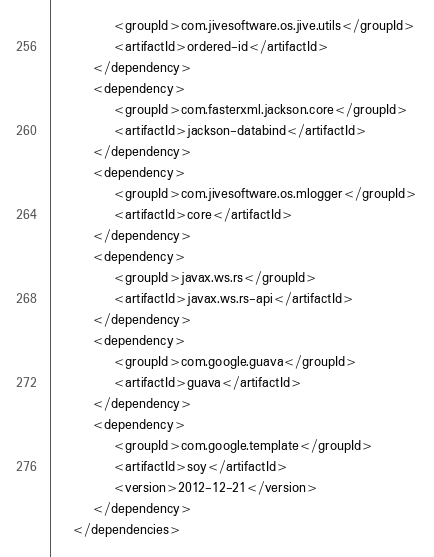Convert code to text. <code><loc_0><loc_0><loc_500><loc_500><_XML_>            <groupId>com.jivesoftware.os.jive.utils</groupId>
            <artifactId>ordered-id</artifactId>
        </dependency>
        <dependency>
            <groupId>com.fasterxml.jackson.core</groupId>
            <artifactId>jackson-databind</artifactId>
        </dependency>
        <dependency>
            <groupId>com.jivesoftware.os.mlogger</groupId>
            <artifactId>core</artifactId>
        </dependency>
        <dependency>
            <groupId>javax.ws.rs</groupId>
            <artifactId>javax.ws.rs-api</artifactId>
        </dependency>
        <dependency>
            <groupId>com.google.guava</groupId>
            <artifactId>guava</artifactId>
        </dependency>
        <dependency>
            <groupId>com.google.template</groupId>
            <artifactId>soy</artifactId>
            <version>2012-12-21</version>
        </dependency>
    </dependencies></code> 